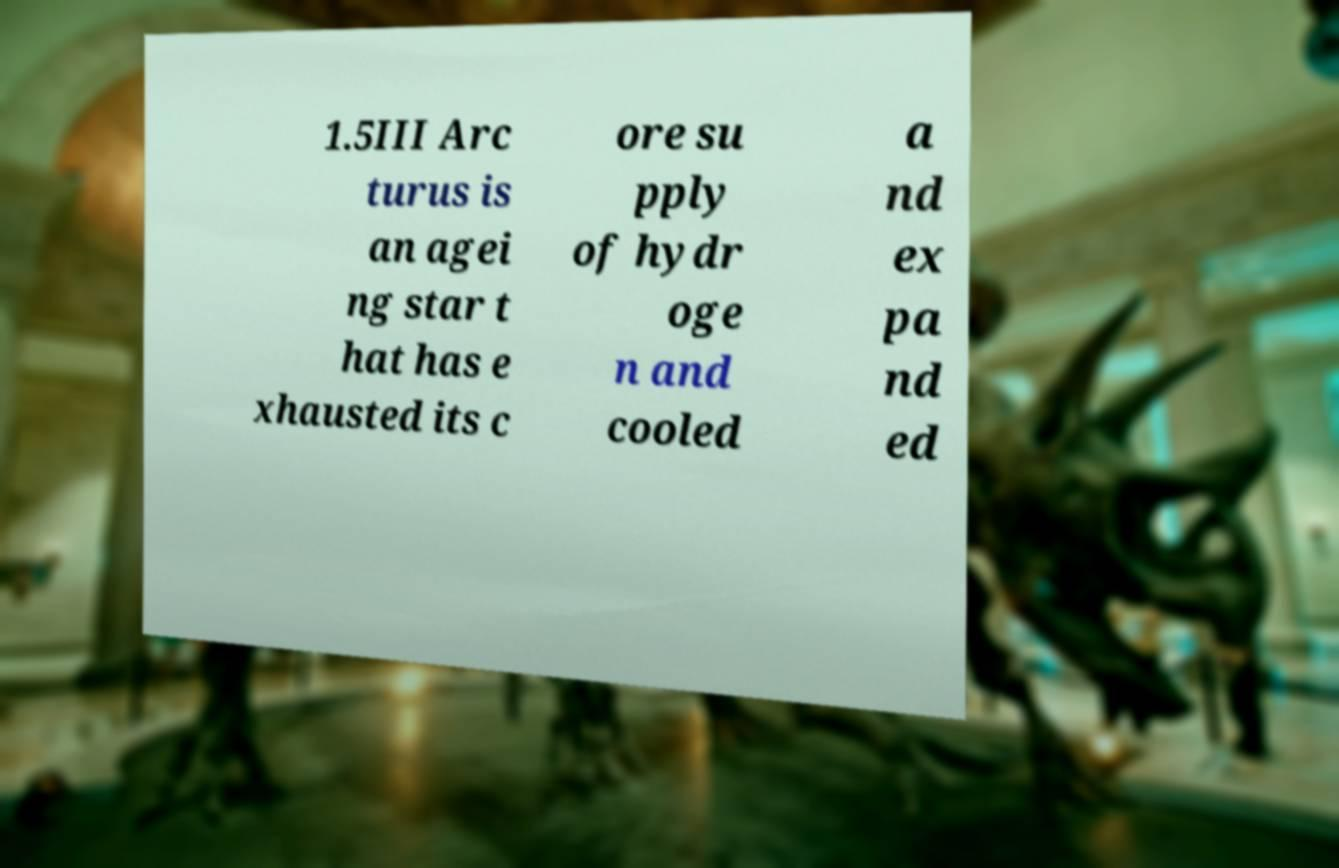For documentation purposes, I need the text within this image transcribed. Could you provide that? 1.5III Arc turus is an agei ng star t hat has e xhausted its c ore su pply of hydr oge n and cooled a nd ex pa nd ed 